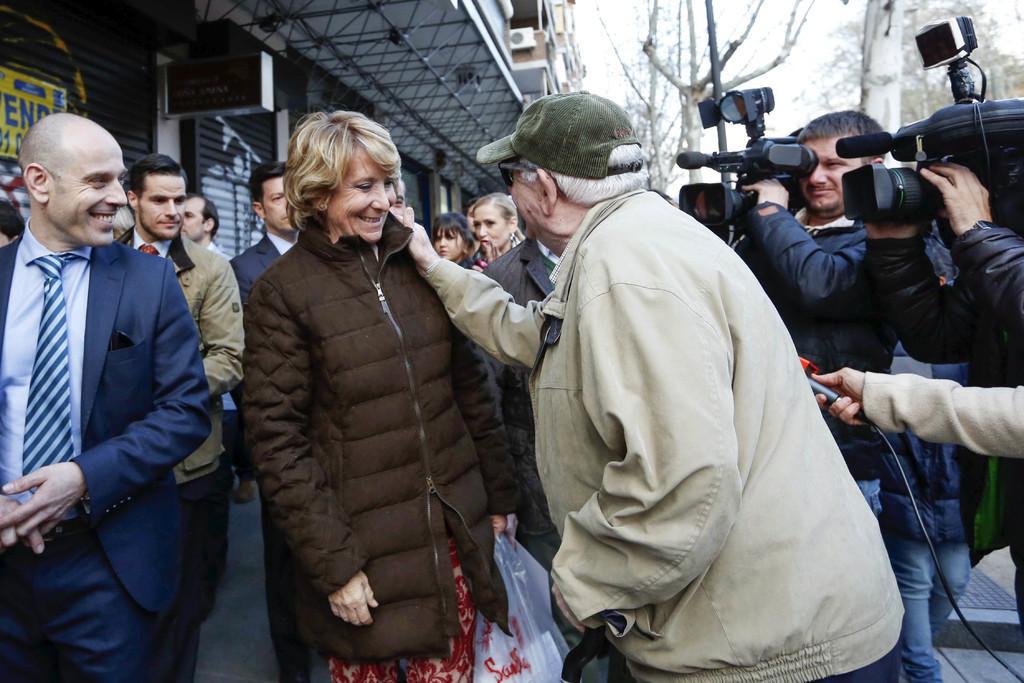Please provide a concise description of this image. In this picture there are people, among them two persons holding cameras. We can see building, board and trees. In the background of the image we can see the sky. 